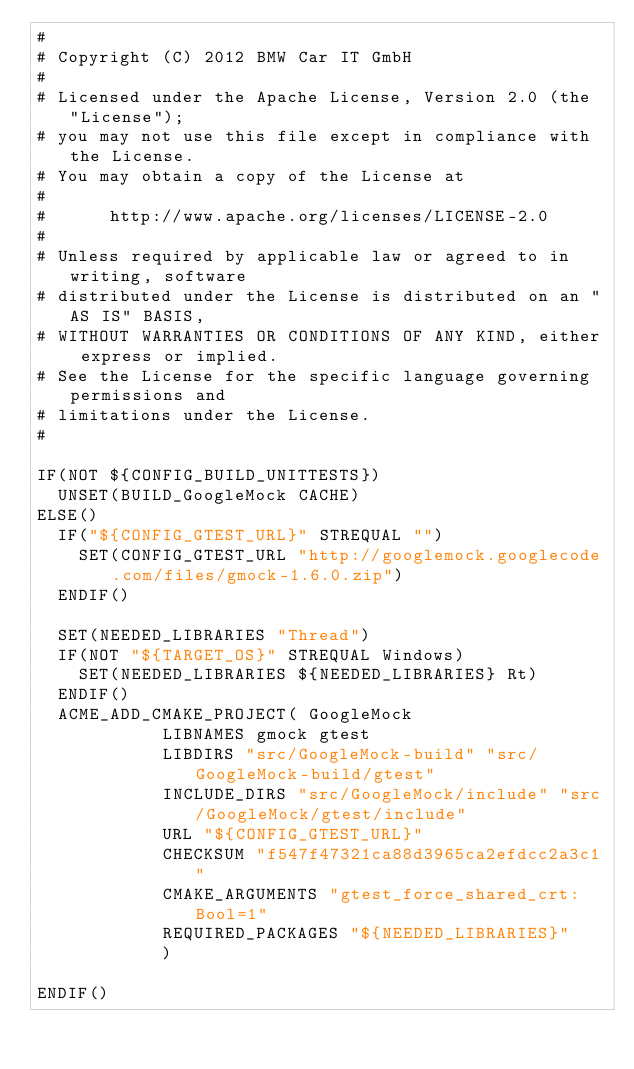<code> <loc_0><loc_0><loc_500><loc_500><_CMake_>#
# Copyright (C) 2012 BMW Car IT GmbH
#
# Licensed under the Apache License, Version 2.0 (the "License");
# you may not use this file except in compliance with the License.
# You may obtain a copy of the License at
#
#      http://www.apache.org/licenses/LICENSE-2.0
#
# Unless required by applicable law or agreed to in writing, software
# distributed under the License is distributed on an "AS IS" BASIS,
# WITHOUT WARRANTIES OR CONDITIONS OF ANY KIND, either express or implied.
# See the License for the specific language governing permissions and
# limitations under the License.
#

IF(NOT ${CONFIG_BUILD_UNITTESTS})
	UNSET(BUILD_GoogleMock CACHE)
ELSE()
	IF("${CONFIG_GTEST_URL}" STREQUAL "")
		SET(CONFIG_GTEST_URL "http://googlemock.googlecode.com/files/gmock-1.6.0.zip")
	ENDIF()

	SET(NEEDED_LIBRARIES "Thread")
	IF(NOT "${TARGET_OS}" STREQUAL Windows)
		SET(NEEDED_LIBRARIES ${NEEDED_LIBRARIES} Rt)
	ENDIF()
	ACME_ADD_CMAKE_PROJECT(	GoogleMock 
						LIBNAMES gmock gtest
						LIBDIRS "src/GoogleMock-build" "src/GoogleMock-build/gtest"
						INCLUDE_DIRS "src/GoogleMock/include" "src/GoogleMock/gtest/include"
						URL "${CONFIG_GTEST_URL}"
						CHECKSUM "f547f47321ca88d3965ca2efdcc2a3c1"
						CMAKE_ARGUMENTS "gtest_force_shared_crt:Bool=1"
						REQUIRED_PACKAGES "${NEEDED_LIBRARIES}"
						)

ENDIF()

</code> 